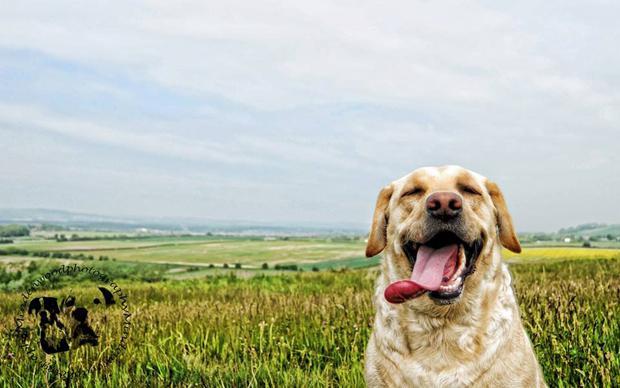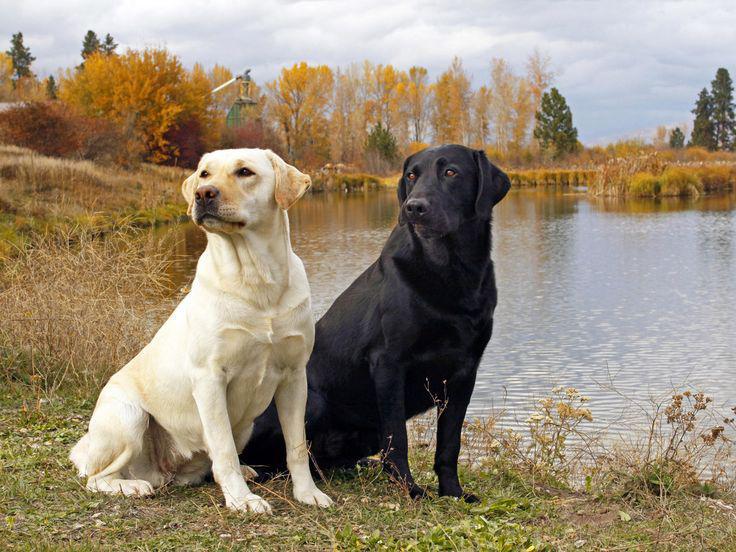The first image is the image on the left, the second image is the image on the right. Assess this claim about the two images: "One image includes exactly two dogs of different colors, and the other features a single dog.". Correct or not? Answer yes or no. Yes. The first image is the image on the left, the second image is the image on the right. Given the left and right images, does the statement "The right image contains at least three dogs." hold true? Answer yes or no. No. 